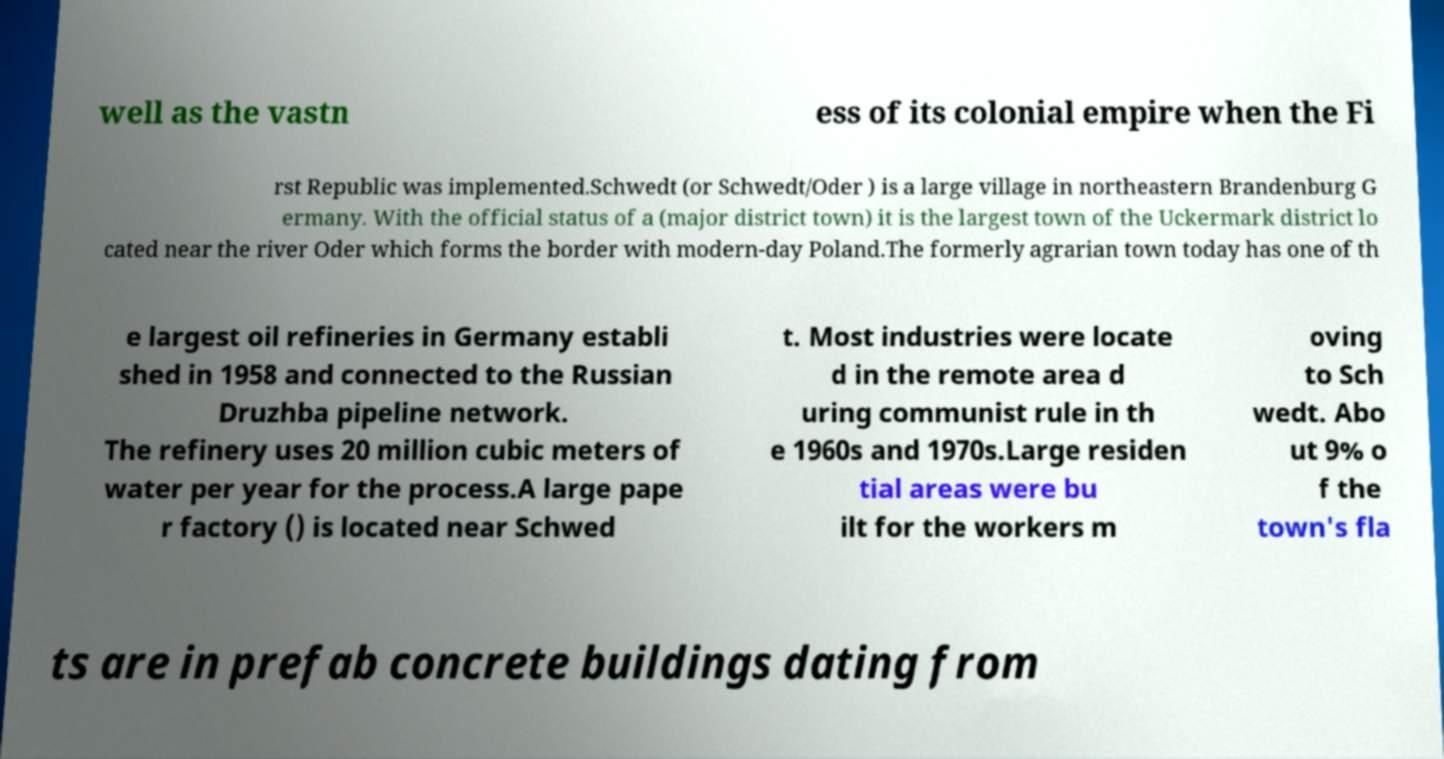Could you extract and type out the text from this image? well as the vastn ess of its colonial empire when the Fi rst Republic was implemented.Schwedt (or Schwedt/Oder ) is a large village in northeastern Brandenburg G ermany. With the official status of a (major district town) it is the largest town of the Uckermark district lo cated near the river Oder which forms the border with modern-day Poland.The formerly agrarian town today has one of th e largest oil refineries in Germany establi shed in 1958 and connected to the Russian Druzhba pipeline network. The refinery uses 20 million cubic meters of water per year for the process.A large pape r factory () is located near Schwed t. Most industries were locate d in the remote area d uring communist rule in th e 1960s and 1970s.Large residen tial areas were bu ilt for the workers m oving to Sch wedt. Abo ut 9% o f the town's fla ts are in prefab concrete buildings dating from 